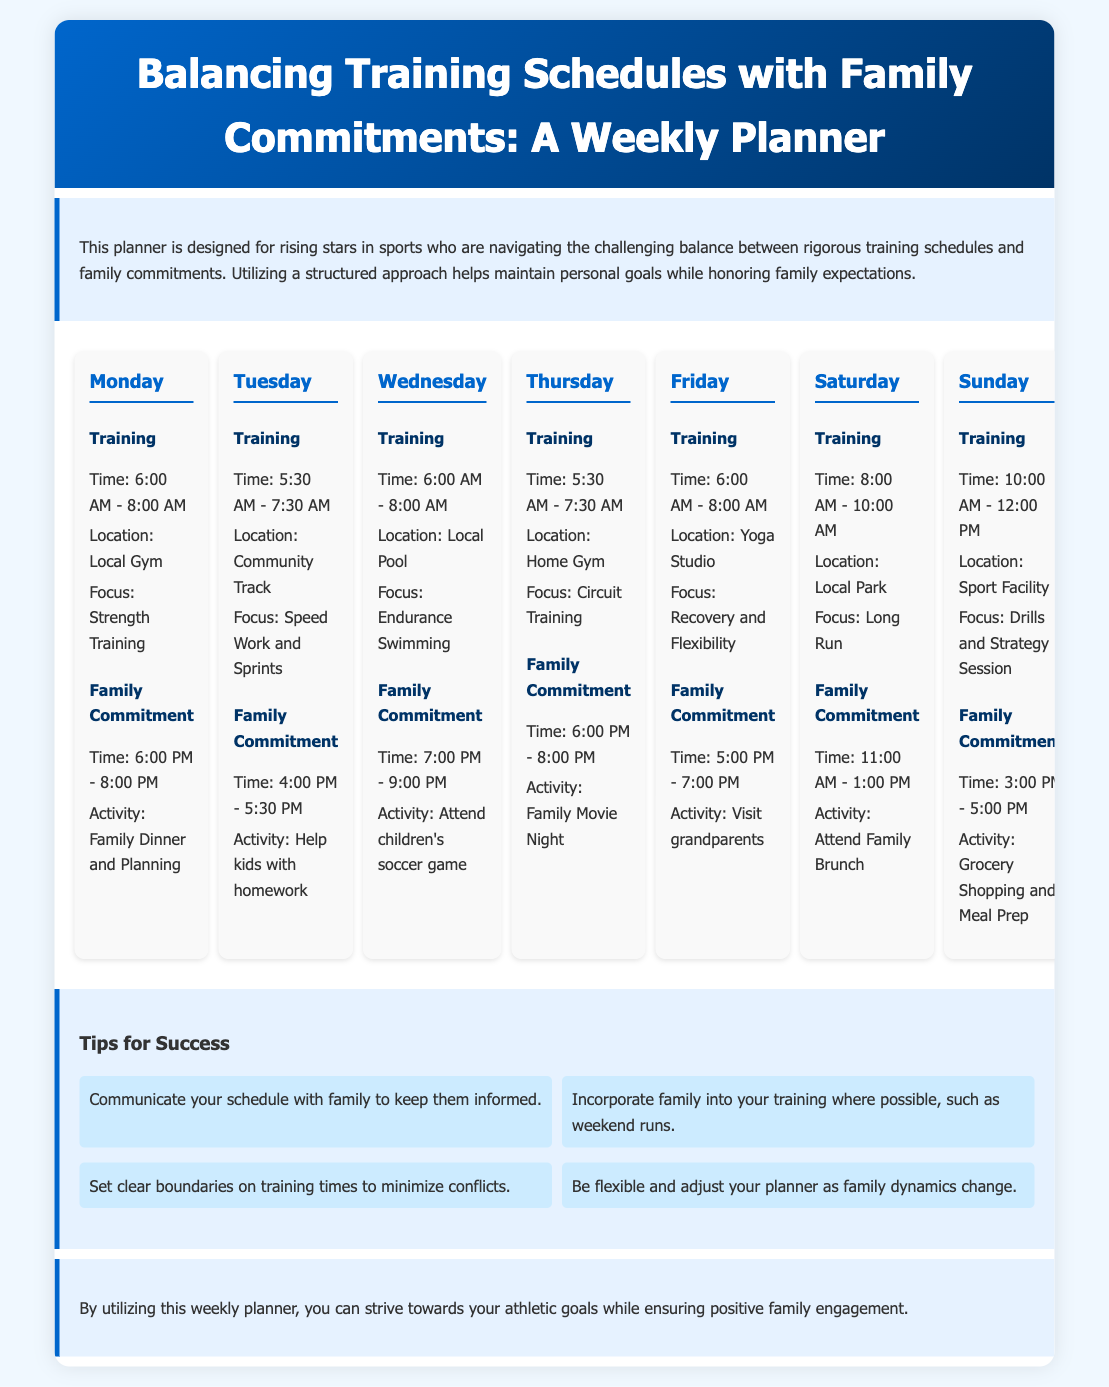What time does training start on Monday? The training on Monday starts at 6:00 AM as indicated in the document.
Answer: 6:00 AM Where is the family commitment on Friday? The family commitment on Friday is to visit grandparents, as listed in the document.
Answer: Visit grandparents What is the focus of the Tuesday training? The focus of the Tuesday training is Speed Work and Sprints, according to the training section.
Answer: Speed Work and Sprints How long is the family commitment on Sunday? The family commitment on Sunday is scheduled from 3:00 PM to 5:00 PM, which is a duration of 2 hours.
Answer: 2 hours What type of training is scheduled for Saturday? The training scheduled for Saturday is a Long Run, as specified in the document.
Answer: Long Run Which day includes Circuit Training? Circuit Training is included in the training schedule on Thursday according to the weekly planner.
Answer: Thursday What activity is planned for Wednesday evening? The planned activity for Wednesday evening is to attend children's soccer game.
Answer: Attend children's soccer game How many tips for success are listed in the document? There are four tips for success provided in the tips section of the document.
Answer: Four tips 